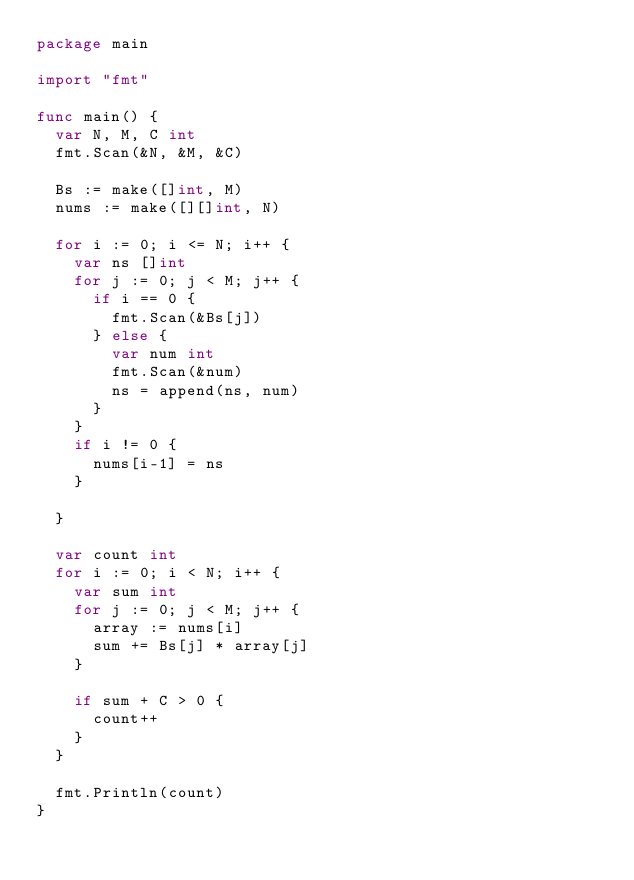<code> <loc_0><loc_0><loc_500><loc_500><_Go_>package main

import "fmt"

func main() {
	var N, M, C int
	fmt.Scan(&N, &M, &C)

	Bs := make([]int, M)
	nums := make([][]int, N)

	for i := 0; i <= N; i++ {
		var ns []int
		for j := 0; j < M; j++ {
			if i == 0 {
				fmt.Scan(&Bs[j])
			} else {
				var num int
				fmt.Scan(&num)
				ns = append(ns, num)
			}
		}
		if i != 0 {
			nums[i-1] = ns
		}

	}

	var count int
	for i := 0; i < N; i++ {
		var sum int
		for j := 0; j < M; j++ {
			array := nums[i]
			sum += Bs[j] * array[j]
		}

		if sum + C > 0 {
			count++
		}
	}

	fmt.Println(count)
}
</code> 